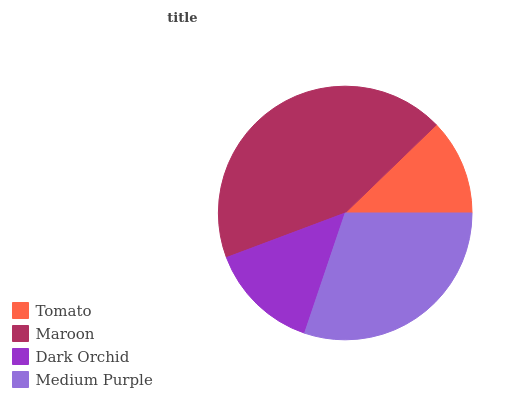Is Tomato the minimum?
Answer yes or no. Yes. Is Maroon the maximum?
Answer yes or no. Yes. Is Dark Orchid the minimum?
Answer yes or no. No. Is Dark Orchid the maximum?
Answer yes or no. No. Is Maroon greater than Dark Orchid?
Answer yes or no. Yes. Is Dark Orchid less than Maroon?
Answer yes or no. Yes. Is Dark Orchid greater than Maroon?
Answer yes or no. No. Is Maroon less than Dark Orchid?
Answer yes or no. No. Is Medium Purple the high median?
Answer yes or no. Yes. Is Dark Orchid the low median?
Answer yes or no. Yes. Is Maroon the high median?
Answer yes or no. No. Is Maroon the low median?
Answer yes or no. No. 